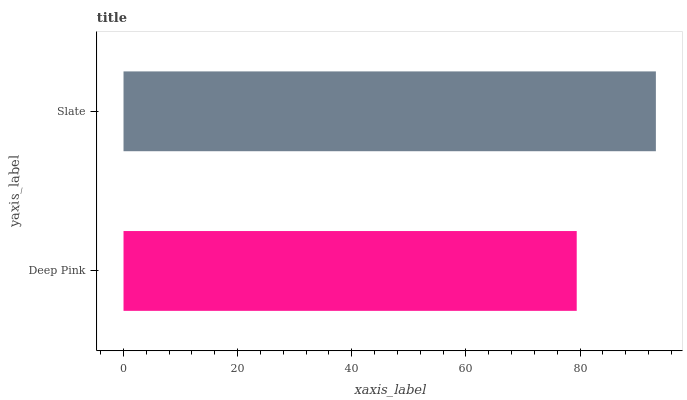Is Deep Pink the minimum?
Answer yes or no. Yes. Is Slate the maximum?
Answer yes or no. Yes. Is Slate the minimum?
Answer yes or no. No. Is Slate greater than Deep Pink?
Answer yes or no. Yes. Is Deep Pink less than Slate?
Answer yes or no. Yes. Is Deep Pink greater than Slate?
Answer yes or no. No. Is Slate less than Deep Pink?
Answer yes or no. No. Is Slate the high median?
Answer yes or no. Yes. Is Deep Pink the low median?
Answer yes or no. Yes. Is Deep Pink the high median?
Answer yes or no. No. Is Slate the low median?
Answer yes or no. No. 